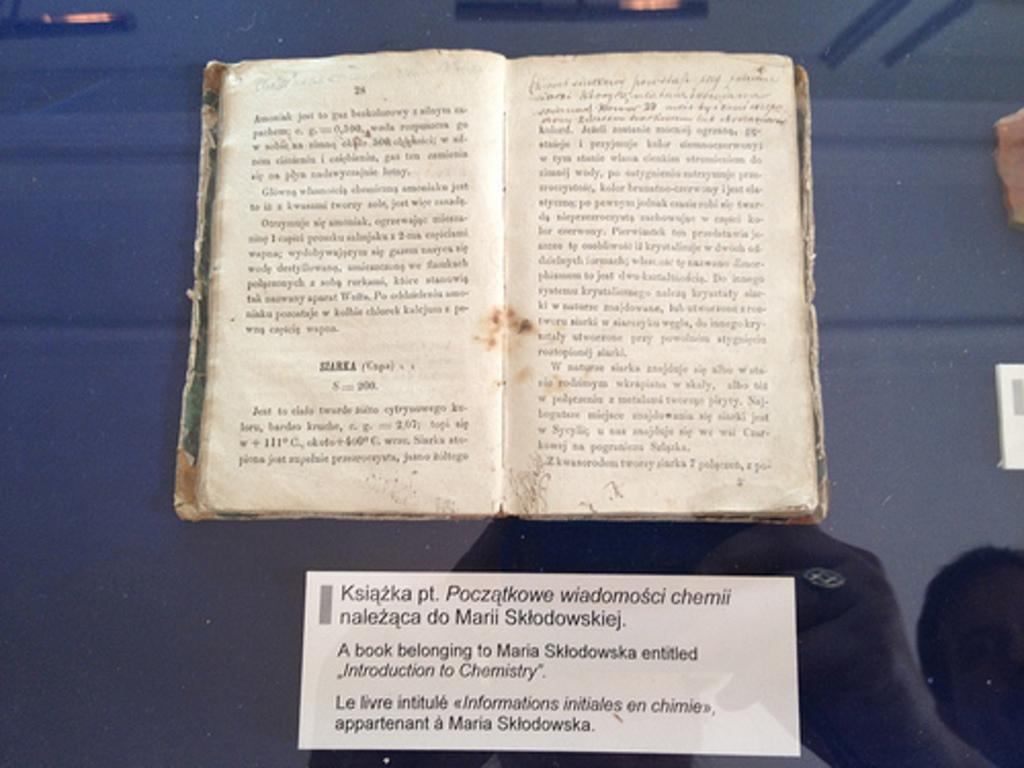Waht is the title of the book?
Your response must be concise. Introduction to chemistry. 